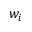Convert formula to latex. <formula><loc_0><loc_0><loc_500><loc_500>w _ { i }</formula> 